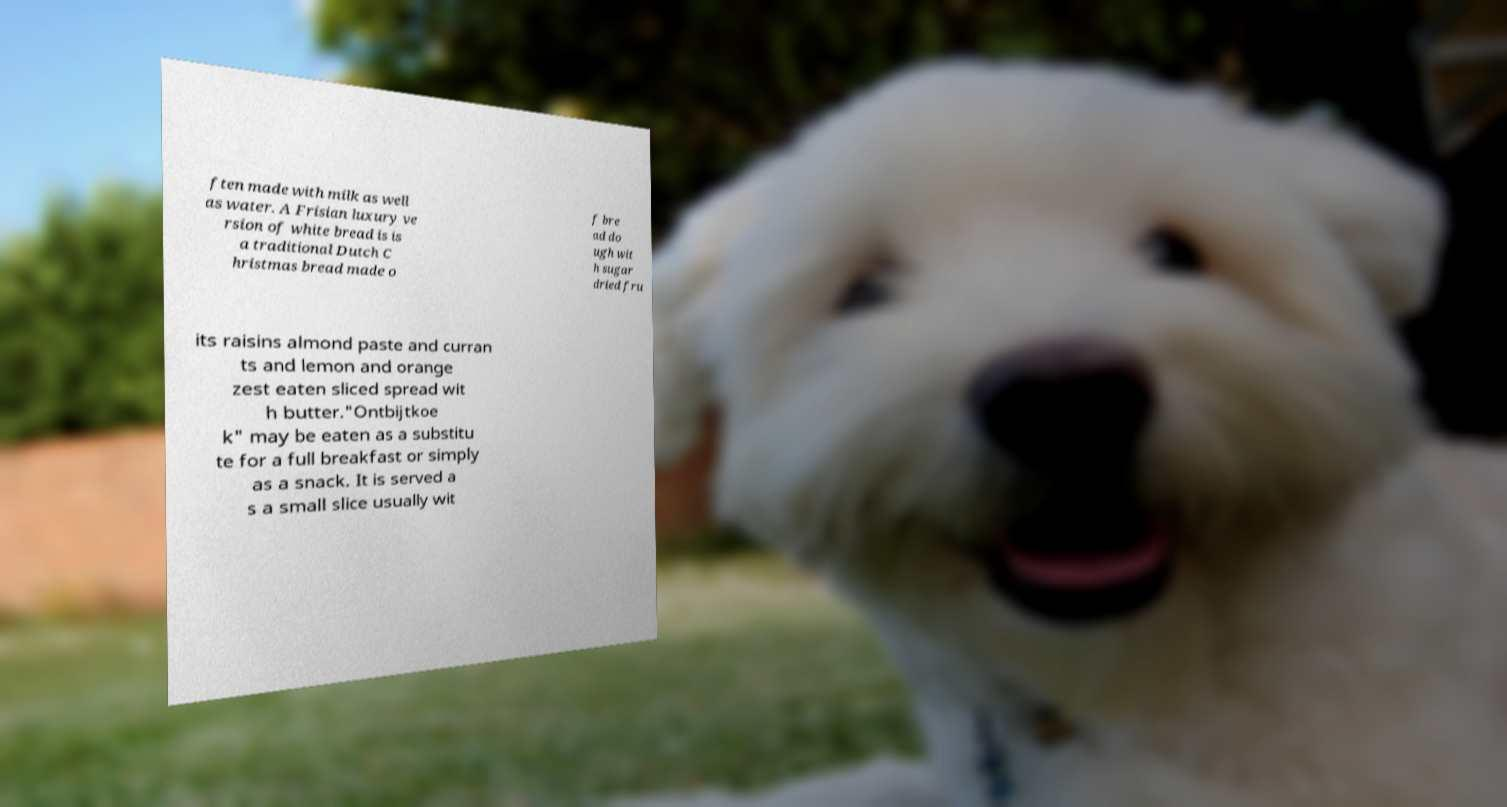What messages or text are displayed in this image? I need them in a readable, typed format. ften made with milk as well as water. A Frisian luxury ve rsion of white bread is is a traditional Dutch C hristmas bread made o f bre ad do ugh wit h sugar dried fru its raisins almond paste and curran ts and lemon and orange zest eaten sliced spread wit h butter."Ontbijtkoe k" may be eaten as a substitu te for a full breakfast or simply as a snack. It is served a s a small slice usually wit 